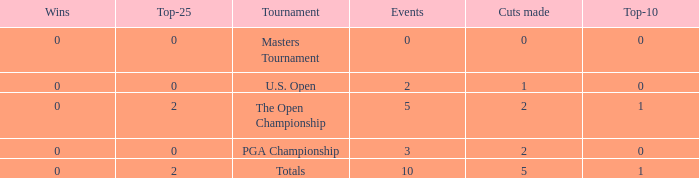What is the total number of cuts made for events played more than 3 times and under 2 top-25s? 0.0. 